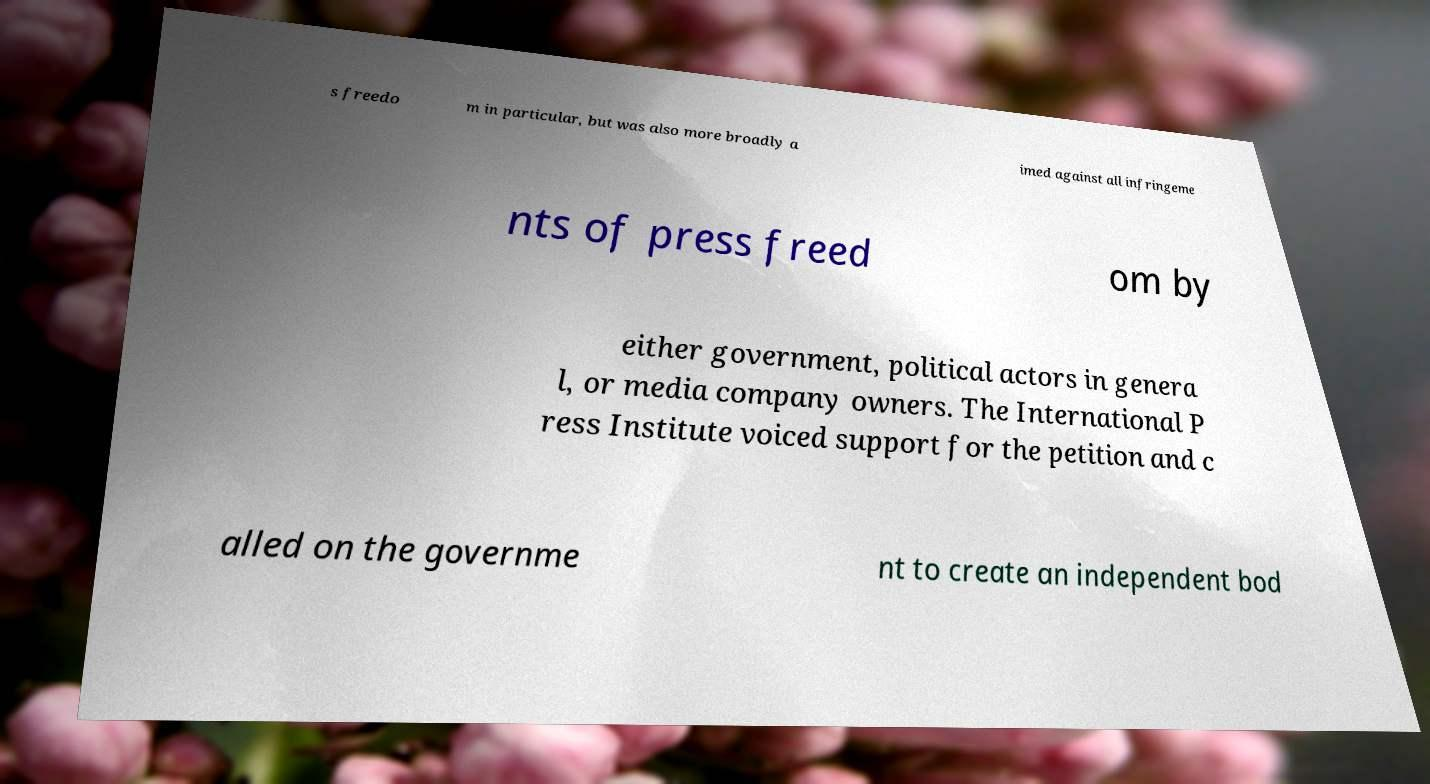Can you accurately transcribe the text from the provided image for me? s freedo m in particular, but was also more broadly a imed against all infringeme nts of press freed om by either government, political actors in genera l, or media company owners. The International P ress Institute voiced support for the petition and c alled on the governme nt to create an independent bod 